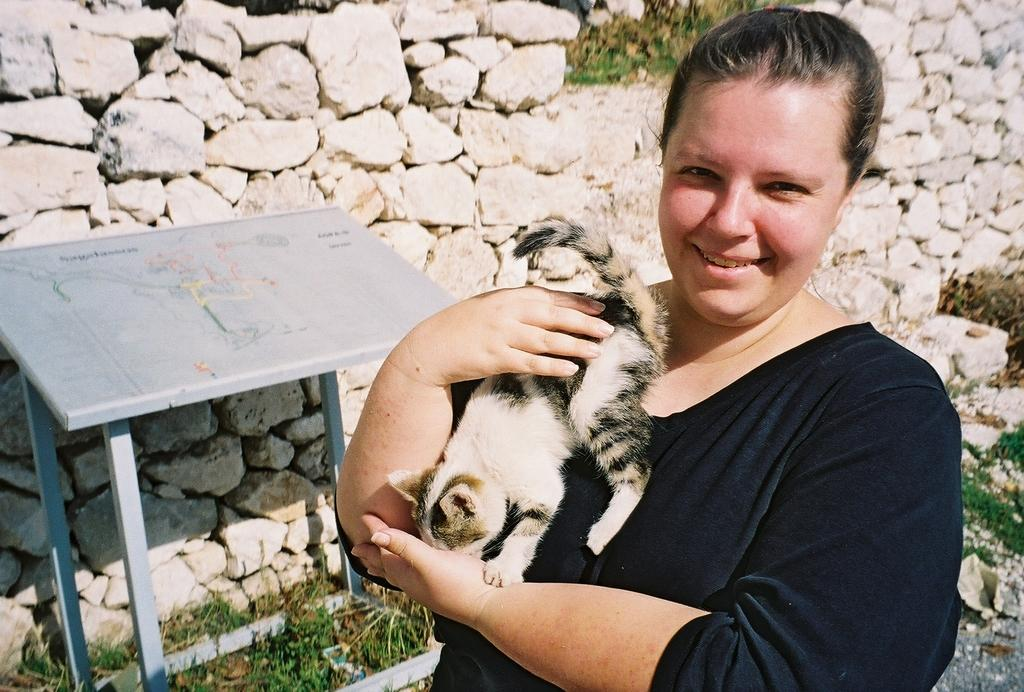What is the woman in the image doing? The woman is standing in the image and holding a cat. Where is the woman and cat located in the image? They are at the bottom of the image. What is on the left side of the image? There is a table on the left side of the image. What can be seen in the background of the image? There is a rock wall in the background of the image. What type of pie is being served by the band in the image? There is no pie or band present in the image; it features a woman holding a cat and a rock wall in the background. 